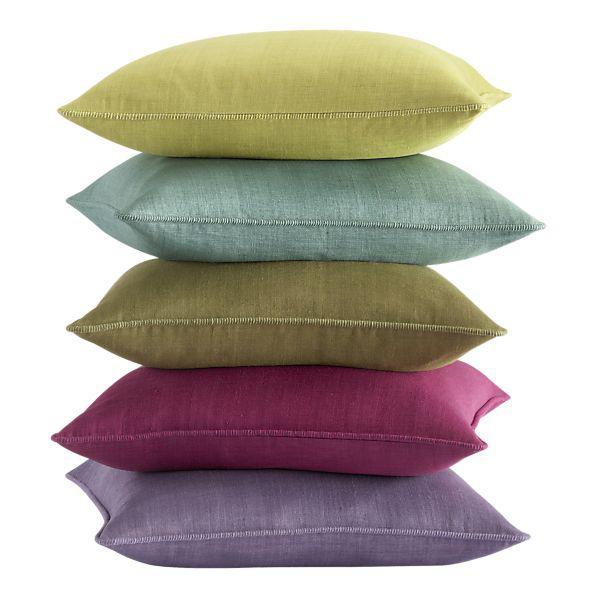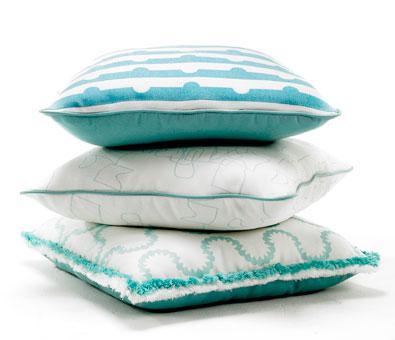The first image is the image on the left, the second image is the image on the right. Examine the images to the left and right. Is the description "The right image is a stack of at least 7 multicolored pillows, while the left image is a single square shaped pillow." accurate? Answer yes or no. No. The first image is the image on the left, the second image is the image on the right. Analyze the images presented: Is the assertion "An image shows a four-sided pillow shape with at least one animal image on it." valid? Answer yes or no. No. 